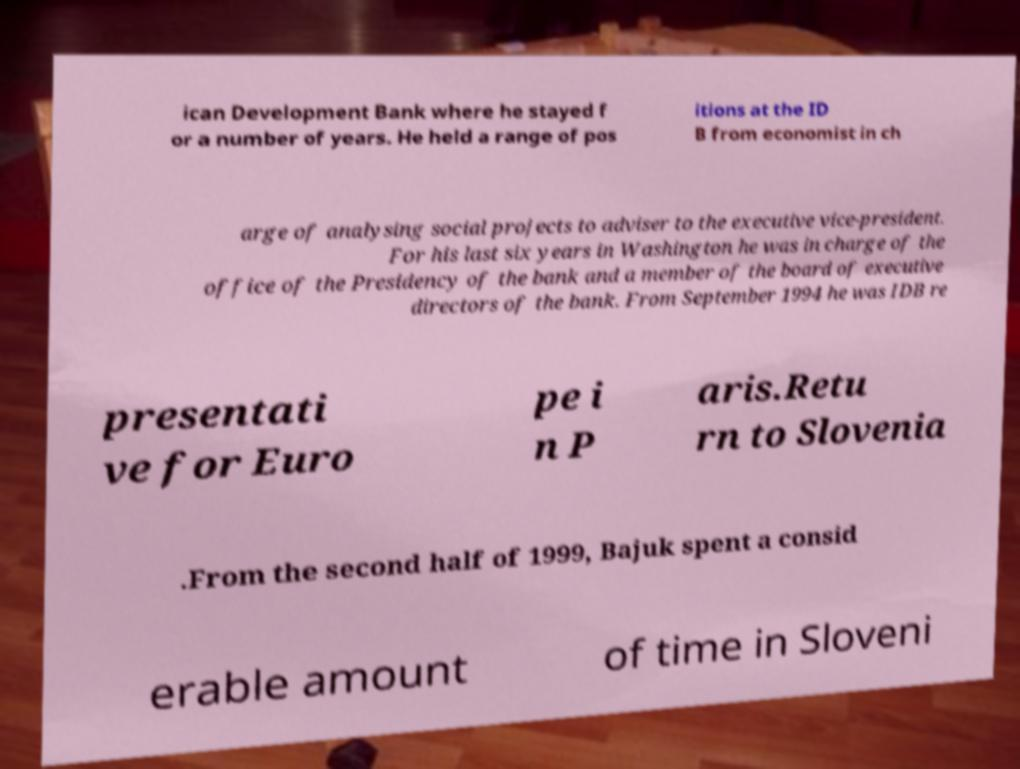Can you read and provide the text displayed in the image?This photo seems to have some interesting text. Can you extract and type it out for me? ican Development Bank where he stayed f or a number of years. He held a range of pos itions at the ID B from economist in ch arge of analysing social projects to adviser to the executive vice-president. For his last six years in Washington he was in charge of the office of the Presidency of the bank and a member of the board of executive directors of the bank. From September 1994 he was IDB re presentati ve for Euro pe i n P aris.Retu rn to Slovenia .From the second half of 1999, Bajuk spent a consid erable amount of time in Sloveni 